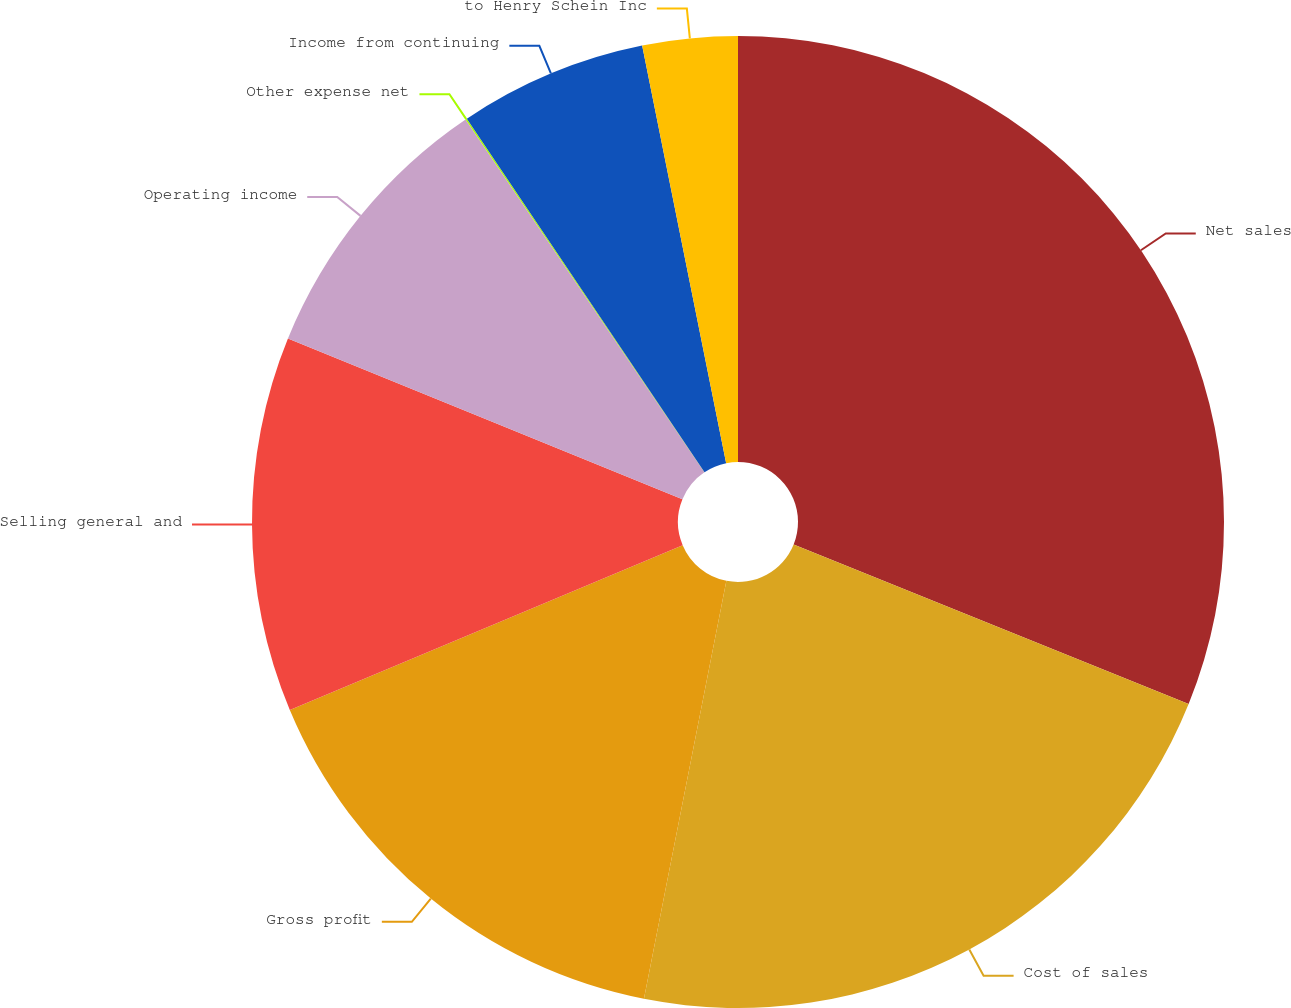Convert chart to OTSL. <chart><loc_0><loc_0><loc_500><loc_500><pie_chart><fcel>Net sales<fcel>Cost of sales<fcel>Gross profit<fcel>Selling general and<fcel>Operating income<fcel>Other expense net<fcel>Income from continuing<fcel>to Henry Schein Inc<nl><fcel>31.11%<fcel>21.99%<fcel>15.58%<fcel>12.48%<fcel>9.37%<fcel>0.05%<fcel>6.26%<fcel>3.16%<nl></chart> 